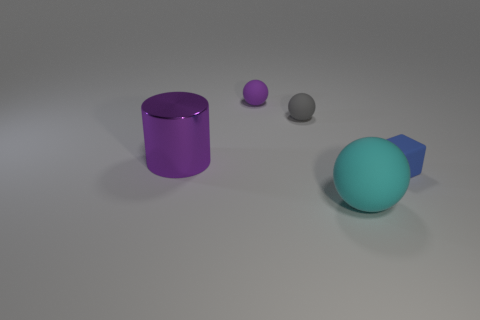Is there anything else that is made of the same material as the large purple cylinder?
Make the answer very short. No. How many things are both in front of the small gray object and to the left of the cyan thing?
Provide a succinct answer. 1. There is a matte block; does it have the same size as the ball in front of the tiny gray matte sphere?
Make the answer very short. No. What is the size of the object right of the rubber sphere in front of the tiny thing in front of the cylinder?
Ensure brevity in your answer.  Small. What is the size of the matte sphere that is to the left of the tiny gray rubber thing?
Keep it short and to the point. Small. There is a cyan thing that is made of the same material as the blue block; what is its shape?
Your answer should be compact. Sphere. Are the thing that is behind the tiny gray rubber ball and the small cube made of the same material?
Your response must be concise. Yes. What number of other objects are there of the same material as the big cylinder?
Make the answer very short. 0. How many objects are large things on the right side of the tiny gray object or objects in front of the tiny gray thing?
Your answer should be very brief. 3. There is a thing left of the small purple thing; is it the same shape as the rubber object that is in front of the tiny blue matte block?
Keep it short and to the point. No. 